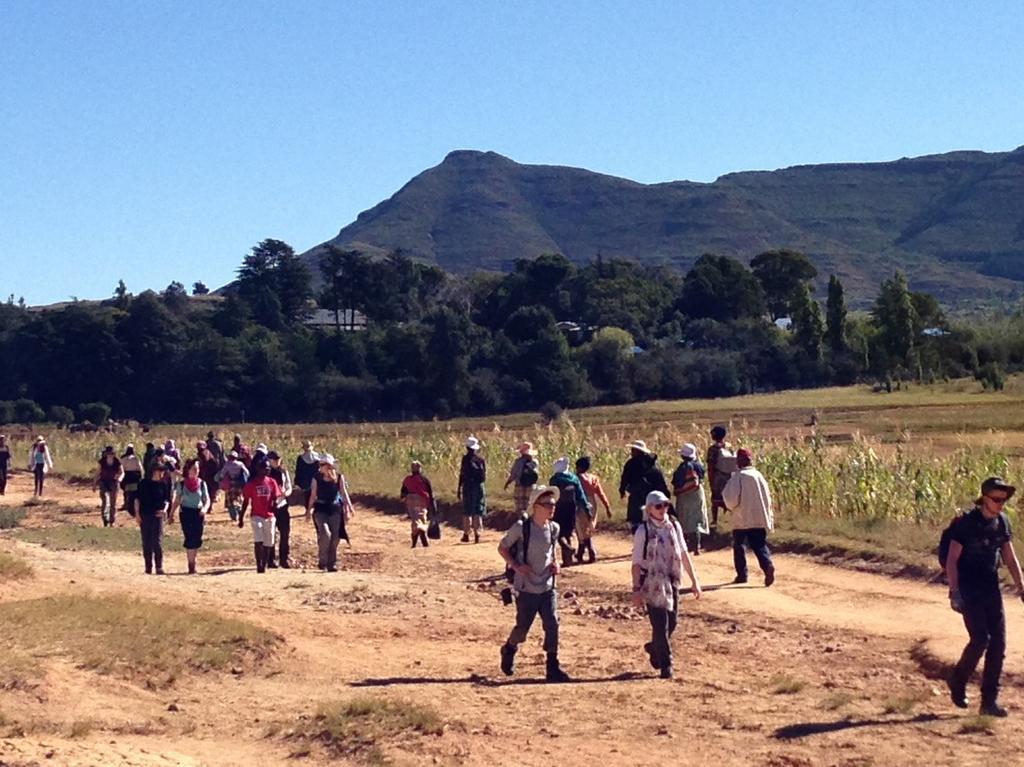Please provide a concise description of this image. In this image I see number of people in which most of them are wearing caps and I see the ground and I see the plants over here. In the background I see number of trees, mountains and the clear sky. 